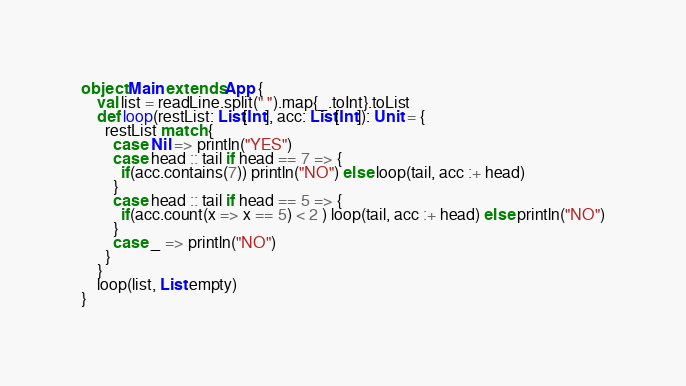Convert code to text. <code><loc_0><loc_0><loc_500><loc_500><_Scala_>object Main extends App {
    val list = readLine.split(" ").map{_.toInt}.toList
    def loop(restList: List[Int], acc: List[Int]): Unit = {
      restList match {
        case Nil => println("YES")
        case head :: tail if head == 7 => {
          if(acc.contains(7)) println("NO") else loop(tail, acc :+ head)
        }
        case head :: tail if head == 5 => {
          if(acc.count(x => x == 5) < 2 ) loop(tail, acc :+ head) else println("NO")
        }
        case _ => println("NO")
      }
    }
    loop(list, List.empty)
}</code> 